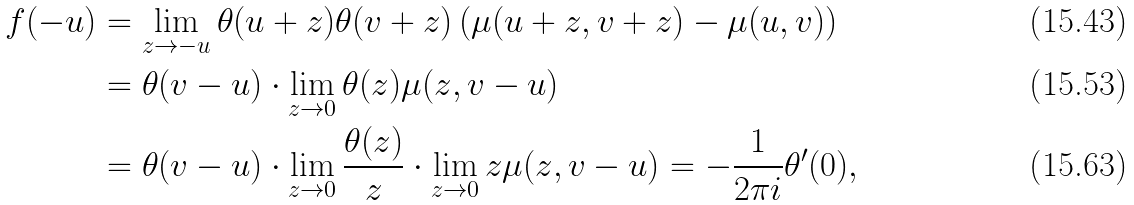Convert formula to latex. <formula><loc_0><loc_0><loc_500><loc_500>f ( - u ) & = \lim _ { z \rightarrow - u } \theta ( u + z ) \theta ( v + z ) \left ( \mu ( u + z , v + z ) - \mu ( u , v ) \right ) \\ & = \theta ( v - u ) \cdot \lim _ { z \rightarrow 0 } \theta ( z ) \mu ( z , v - u ) \\ & = \theta ( v - u ) \cdot \lim _ { z \rightarrow 0 } \frac { \theta ( z ) } { z } \cdot \lim _ { z \rightarrow 0 } z \mu ( z , v - u ) = - \frac { 1 } { 2 \pi i } \theta ^ { \prime } ( 0 ) ,</formula> 